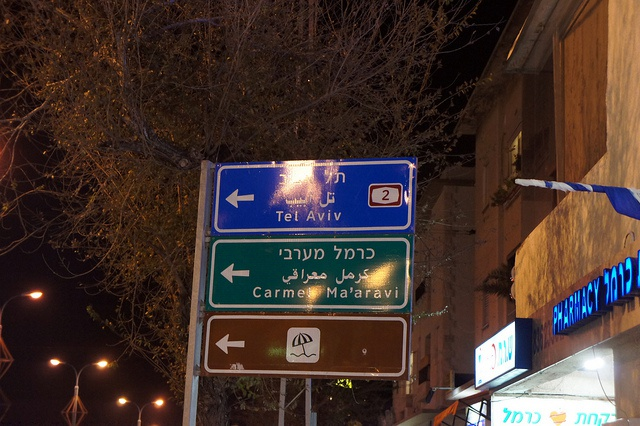Describe the objects in this image and their specific colors. I can see various objects in this image with different colors. 